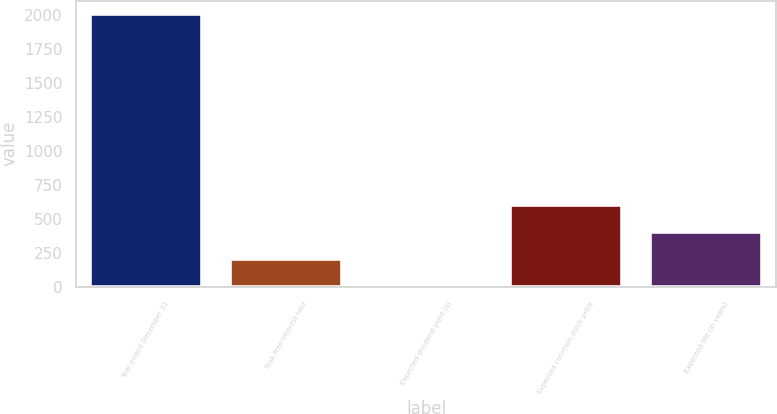<chart> <loc_0><loc_0><loc_500><loc_500><bar_chart><fcel>Year ended December 31<fcel>Risk-free interest rate<fcel>Expected dividend yield (a)<fcel>Expected common stock price<fcel>Expected life (in years)<nl><fcel>2008<fcel>204.01<fcel>3.57<fcel>604.89<fcel>404.45<nl></chart> 